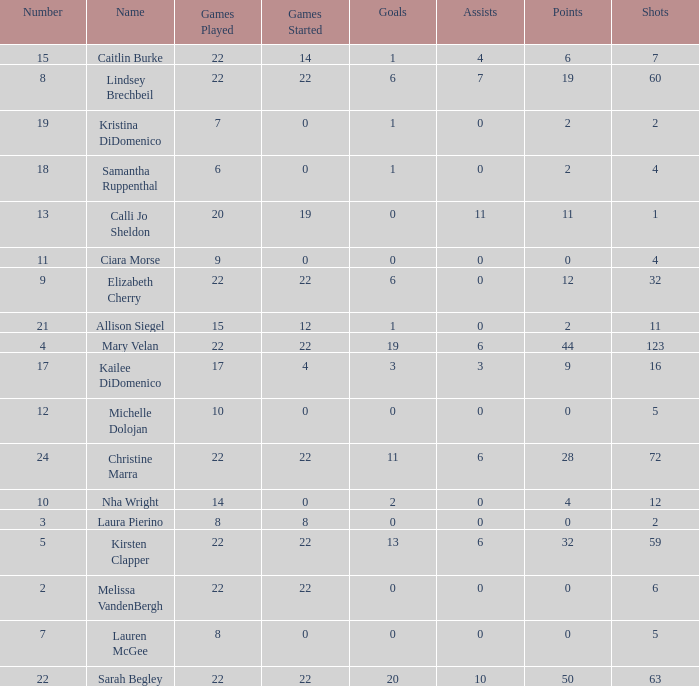How many numbers belong to the player with 10 assists?  1.0. 